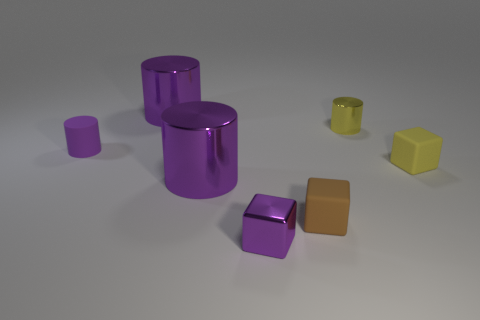Are there an equal number of yellow objects in front of the small yellow cylinder and big purple cylinders that are behind the tiny purple rubber cylinder?
Provide a short and direct response. Yes. There is a rubber thing that is the same shape as the small yellow metal thing; what is its size?
Your response must be concise. Small. There is a rubber object that is left of the small yellow matte thing and on the right side of the tiny metallic cube; what size is it?
Keep it short and to the point. Small. There is a purple rubber cylinder; are there any small rubber cubes behind it?
Provide a short and direct response. No. What number of objects are matte things that are on the left side of the tiny yellow rubber object or blocks?
Ensure brevity in your answer.  4. What number of purple matte cylinders are left of the tiny cylinder that is in front of the tiny yellow shiny cylinder?
Provide a short and direct response. 0. Are there fewer large metal things behind the tiny purple cylinder than small metal cubes that are to the right of the small brown matte block?
Your answer should be compact. No. What shape is the large object that is behind the large purple object that is in front of the yellow cube?
Ensure brevity in your answer.  Cylinder. What number of other objects are there of the same material as the tiny purple block?
Make the answer very short. 3. Is there anything else that is the same size as the purple block?
Your answer should be very brief. Yes. 